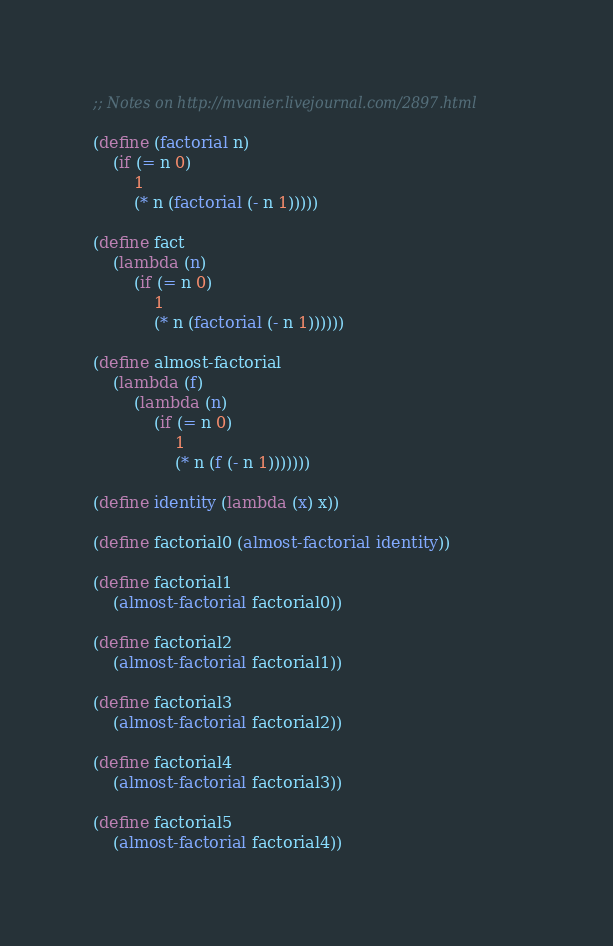Convert code to text. <code><loc_0><loc_0><loc_500><loc_500><_Scheme_>;; Notes on http://mvanier.livejournal.com/2897.html

(define (factorial n)
	(if (= n 0)
		1
		(* n (factorial (- n 1)))))

(define fact
	(lambda (n)
		(if (= n 0)
			1
			(* n (factorial (- n 1))))))

(define almost-factorial
	(lambda (f)
		(lambda (n)
			(if (= n 0)
				1
				(* n (f (- n 1)))))))

(define identity (lambda (x) x))

(define factorial0 (almost-factorial identity))

(define factorial1
	(almost-factorial factorial0))

(define factorial2
	(almost-factorial factorial1))

(define factorial3
	(almost-factorial factorial2))

(define factorial4
	(almost-factorial factorial3))

(define factorial5
	(almost-factorial factorial4))

</code> 